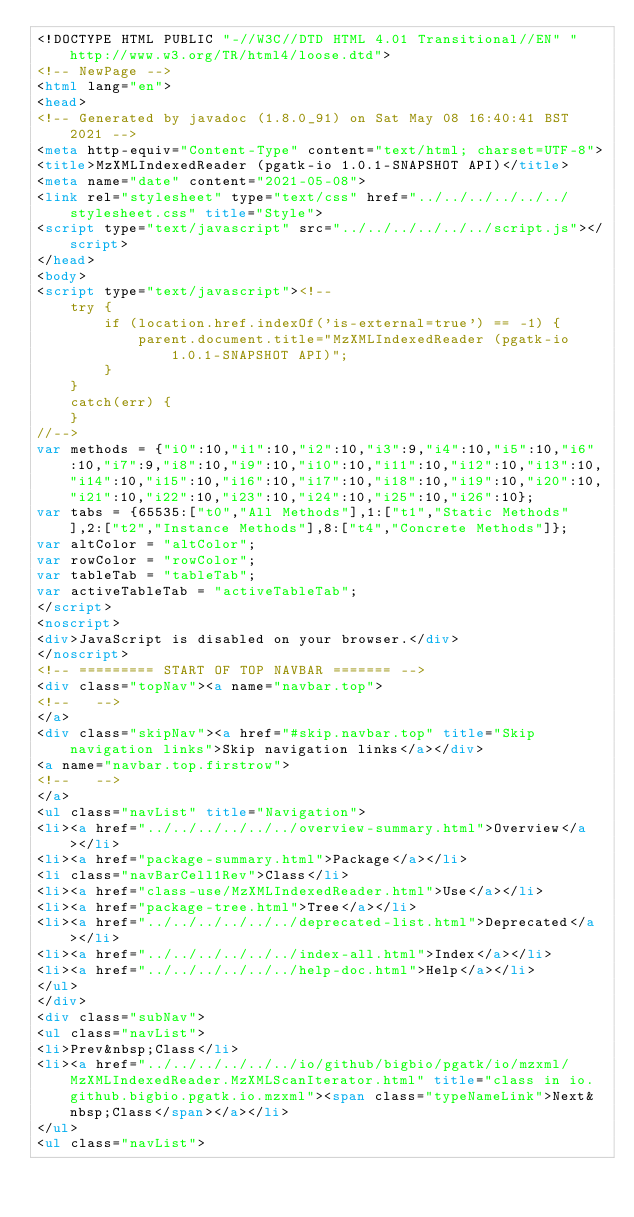<code> <loc_0><loc_0><loc_500><loc_500><_HTML_><!DOCTYPE HTML PUBLIC "-//W3C//DTD HTML 4.01 Transitional//EN" "http://www.w3.org/TR/html4/loose.dtd">
<!-- NewPage -->
<html lang="en">
<head>
<!-- Generated by javadoc (1.8.0_91) on Sat May 08 16:40:41 BST 2021 -->
<meta http-equiv="Content-Type" content="text/html; charset=UTF-8">
<title>MzXMLIndexedReader (pgatk-io 1.0.1-SNAPSHOT API)</title>
<meta name="date" content="2021-05-08">
<link rel="stylesheet" type="text/css" href="../../../../../../stylesheet.css" title="Style">
<script type="text/javascript" src="../../../../../../script.js"></script>
</head>
<body>
<script type="text/javascript"><!--
    try {
        if (location.href.indexOf('is-external=true') == -1) {
            parent.document.title="MzXMLIndexedReader (pgatk-io 1.0.1-SNAPSHOT API)";
        }
    }
    catch(err) {
    }
//-->
var methods = {"i0":10,"i1":10,"i2":10,"i3":9,"i4":10,"i5":10,"i6":10,"i7":9,"i8":10,"i9":10,"i10":10,"i11":10,"i12":10,"i13":10,"i14":10,"i15":10,"i16":10,"i17":10,"i18":10,"i19":10,"i20":10,"i21":10,"i22":10,"i23":10,"i24":10,"i25":10,"i26":10};
var tabs = {65535:["t0","All Methods"],1:["t1","Static Methods"],2:["t2","Instance Methods"],8:["t4","Concrete Methods"]};
var altColor = "altColor";
var rowColor = "rowColor";
var tableTab = "tableTab";
var activeTableTab = "activeTableTab";
</script>
<noscript>
<div>JavaScript is disabled on your browser.</div>
</noscript>
<!-- ========= START OF TOP NAVBAR ======= -->
<div class="topNav"><a name="navbar.top">
<!--   -->
</a>
<div class="skipNav"><a href="#skip.navbar.top" title="Skip navigation links">Skip navigation links</a></div>
<a name="navbar.top.firstrow">
<!--   -->
</a>
<ul class="navList" title="Navigation">
<li><a href="../../../../../../overview-summary.html">Overview</a></li>
<li><a href="package-summary.html">Package</a></li>
<li class="navBarCell1Rev">Class</li>
<li><a href="class-use/MzXMLIndexedReader.html">Use</a></li>
<li><a href="package-tree.html">Tree</a></li>
<li><a href="../../../../../../deprecated-list.html">Deprecated</a></li>
<li><a href="../../../../../../index-all.html">Index</a></li>
<li><a href="../../../../../../help-doc.html">Help</a></li>
</ul>
</div>
<div class="subNav">
<ul class="navList">
<li>Prev&nbsp;Class</li>
<li><a href="../../../../../../io/github/bigbio/pgatk/io/mzxml/MzXMLIndexedReader.MzXMLScanIterator.html" title="class in io.github.bigbio.pgatk.io.mzxml"><span class="typeNameLink">Next&nbsp;Class</span></a></li>
</ul>
<ul class="navList"></code> 